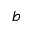Convert formula to latex. <formula><loc_0><loc_0><loc_500><loc_500>b</formula> 